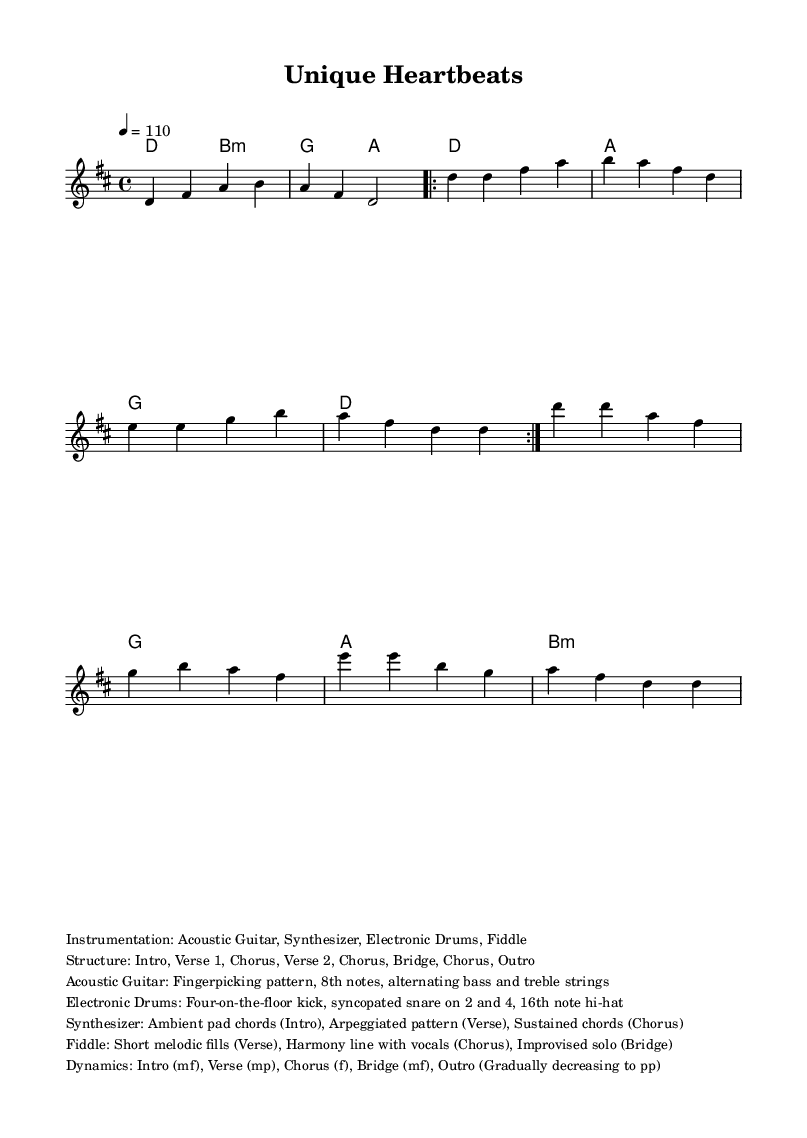What is the key signature of this music? The key signature is D major, which has two sharps: F# and C#. You can identify the key signature in the music sheet, where the sharps are placed.
Answer: D major What is the time signature of this music? The time signature is indicated as 4/4, meaning there are four beats in each measure and a quarter note gets one beat. This can be seen at the beginning of the score.
Answer: 4/4 What is the tempo of the piece? The tempo is marked as 110 beats per minute, indicated by the tempo marking in the music sheet. This informs the performer how quickly to play the piece.
Answer: 110 How many sections are in the structure of the music? The structure has eight sections, including the Intro, two Verses, three Choruses, and a Bridge. This is summarized in the markup section of the code.
Answer: Eight What instrumentation is used in this piece? The instrumentation includes Acoustic Guitar, Synthesizer, Electronic Drums, and Fiddle, as listed in the markup. Each of these instruments contributes to the fusion style of the piece.
Answer: Acoustic Guitar, Synthesizer, Electronic Drums, Fiddle What type of dynamics are applied in the Chorus section? The dynamics in the Chorus section are marked as forte (f), indicating a loud and strong playing style that gives the section emphasis. This can be inferred from the dynamics in the markup.
Answer: Forte How would you describe the rhythm pattern of the Electronic Drums? The rhythm pattern consists of a four-on-the-floor kick on every beat and a syncopated snare on beats 2 and 4, which provides a danceable groove typical of fusion music. This is explains the Drums' rhythmic role mentioned in the markup.
Answer: Four-on-the-floor kick, syncopated snare 